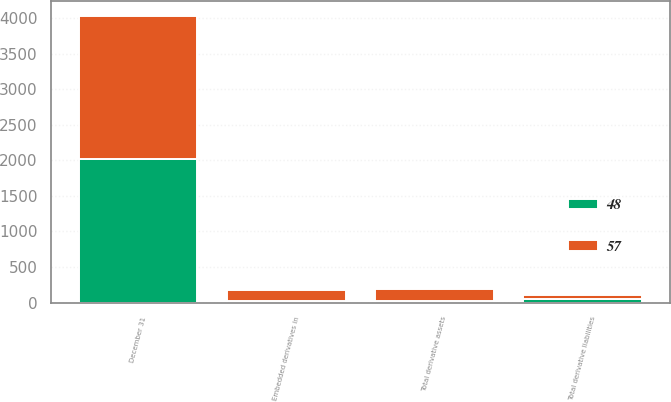Convert chart to OTSL. <chart><loc_0><loc_0><loc_500><loc_500><stacked_bar_chart><ecel><fcel>December 31<fcel>Embedded derivatives in<fcel>Total derivative assets<fcel>Total derivative liabilities<nl><fcel>48<fcel>2018<fcel>23<fcel>23<fcel>48<nl><fcel>57<fcel>2017<fcel>155<fcel>167<fcel>57<nl></chart> 